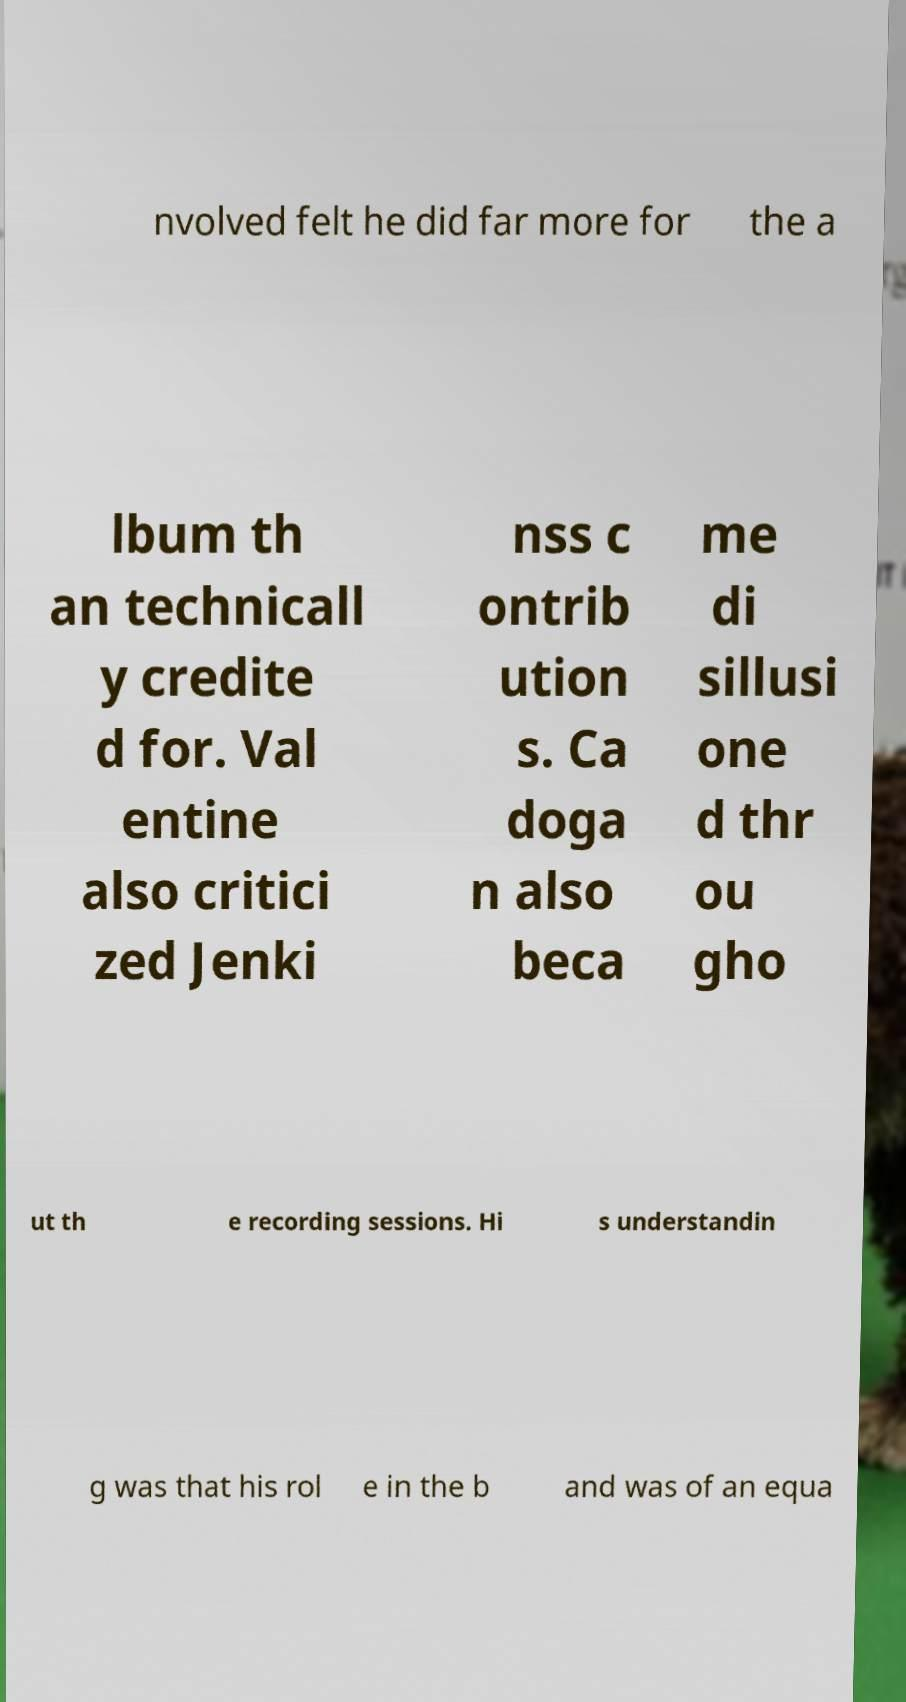Can you read and provide the text displayed in the image?This photo seems to have some interesting text. Can you extract and type it out for me? nvolved felt he did far more for the a lbum th an technicall y credite d for. Val entine also critici zed Jenki nss c ontrib ution s. Ca doga n also beca me di sillusi one d thr ou gho ut th e recording sessions. Hi s understandin g was that his rol e in the b and was of an equa 